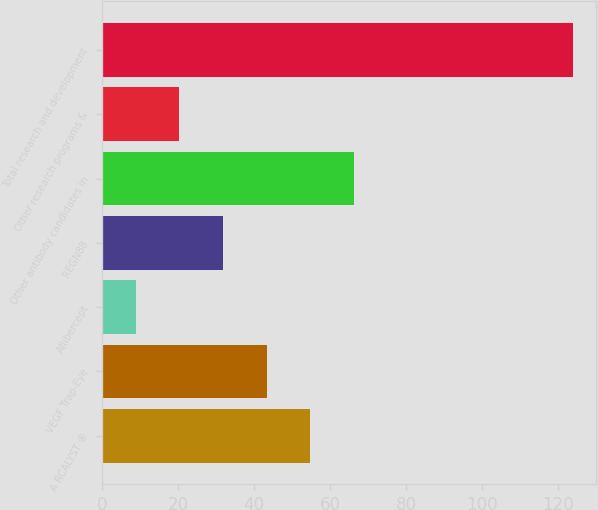Convert chart. <chart><loc_0><loc_0><loc_500><loc_500><bar_chart><fcel>A RCALYST ®<fcel>VEGF Trap-Eye<fcel>Aflibercept<fcel>REGN88<fcel>Other antibody candidates in<fcel>Other research programs &<fcel>Total research and development<nl><fcel>54.84<fcel>43.33<fcel>8.8<fcel>31.82<fcel>66.35<fcel>20.31<fcel>123.9<nl></chart> 